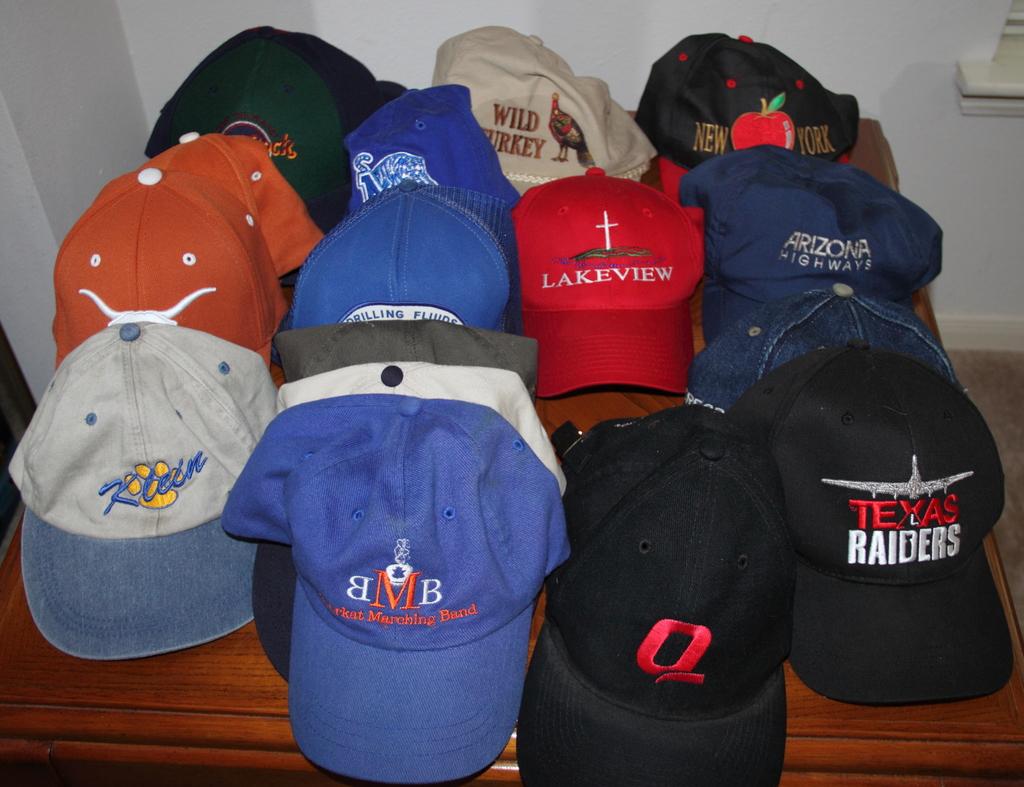What color is 'texas' on the right most cap?
Ensure brevity in your answer.  Red. 